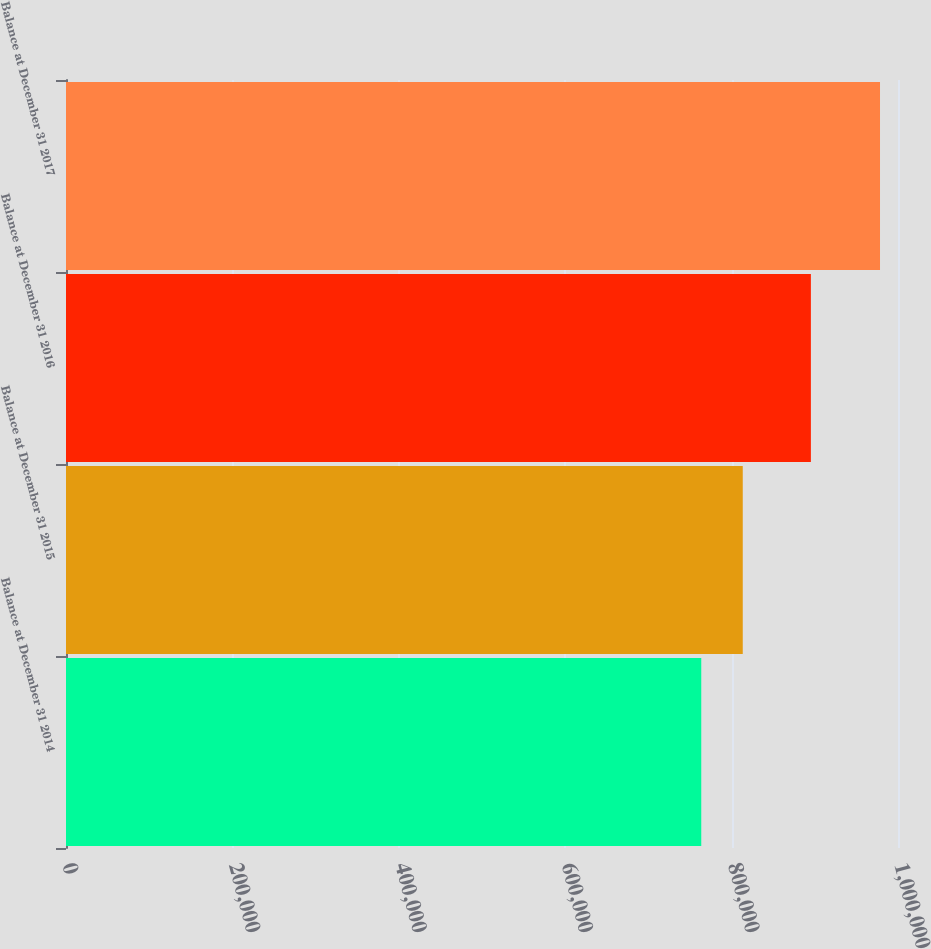Convert chart. <chart><loc_0><loc_0><loc_500><loc_500><bar_chart><fcel>Balance at December 31 2014<fcel>Balance at December 31 2015<fcel>Balance at December 31 2016<fcel>Balance at December 31 2017<nl><fcel>763534<fcel>813414<fcel>895298<fcel>978377<nl></chart> 